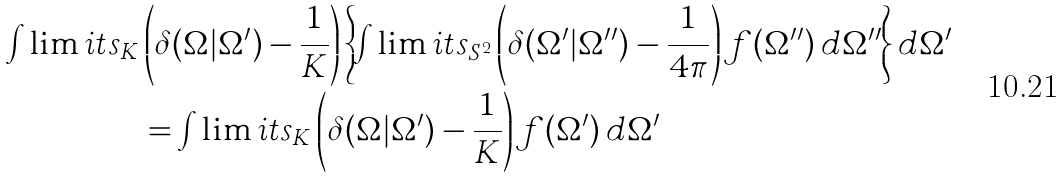Convert formula to latex. <formula><loc_0><loc_0><loc_500><loc_500>\int \lim i t s _ { K } & \left ( \delta ( \Omega | \Omega ^ { \prime } ) - \frac { 1 } { K } \right ) \left \{ \int \lim i t s _ { S ^ { 2 } } \left ( \delta ( \Omega ^ { \prime } | \Omega ^ { \prime \prime } ) - \frac { 1 } { 4 \pi } \right ) f ( \Omega ^ { \prime \prime } ) \, d \Omega ^ { \prime \prime } \right \} d \Omega ^ { \prime } \\ & = \int \lim i t s _ { K } \left ( \delta ( \Omega | \Omega ^ { \prime } ) - \frac { 1 } { K } \right ) f ( \Omega ^ { \prime } ) \, d \Omega ^ { \prime }</formula> 